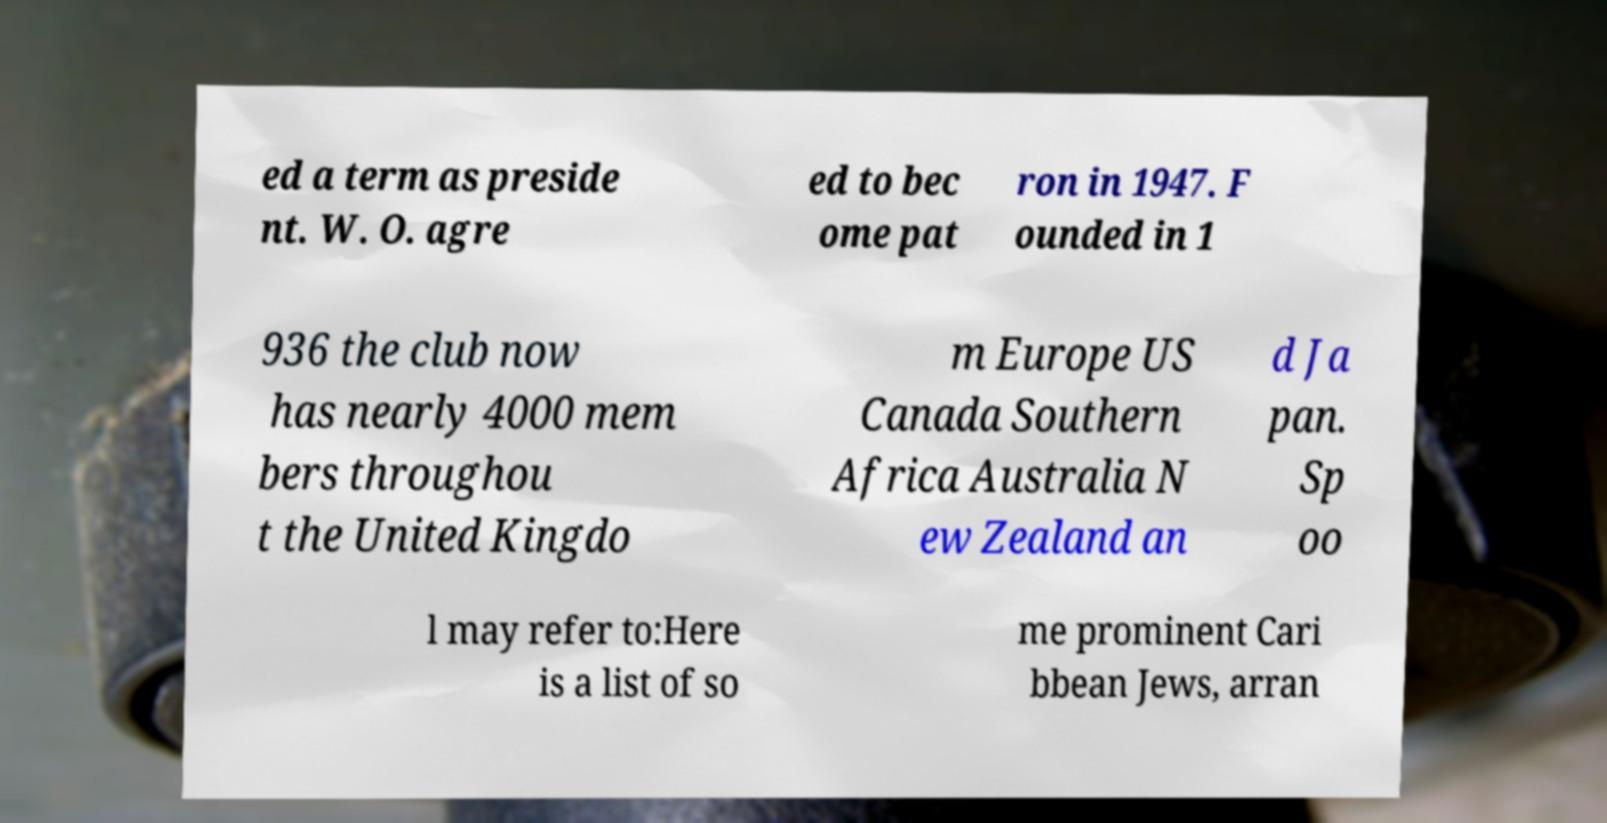Can you accurately transcribe the text from the provided image for me? ed a term as preside nt. W. O. agre ed to bec ome pat ron in 1947. F ounded in 1 936 the club now has nearly 4000 mem bers throughou t the United Kingdo m Europe US Canada Southern Africa Australia N ew Zealand an d Ja pan. Sp oo l may refer to:Here is a list of so me prominent Cari bbean Jews, arran 